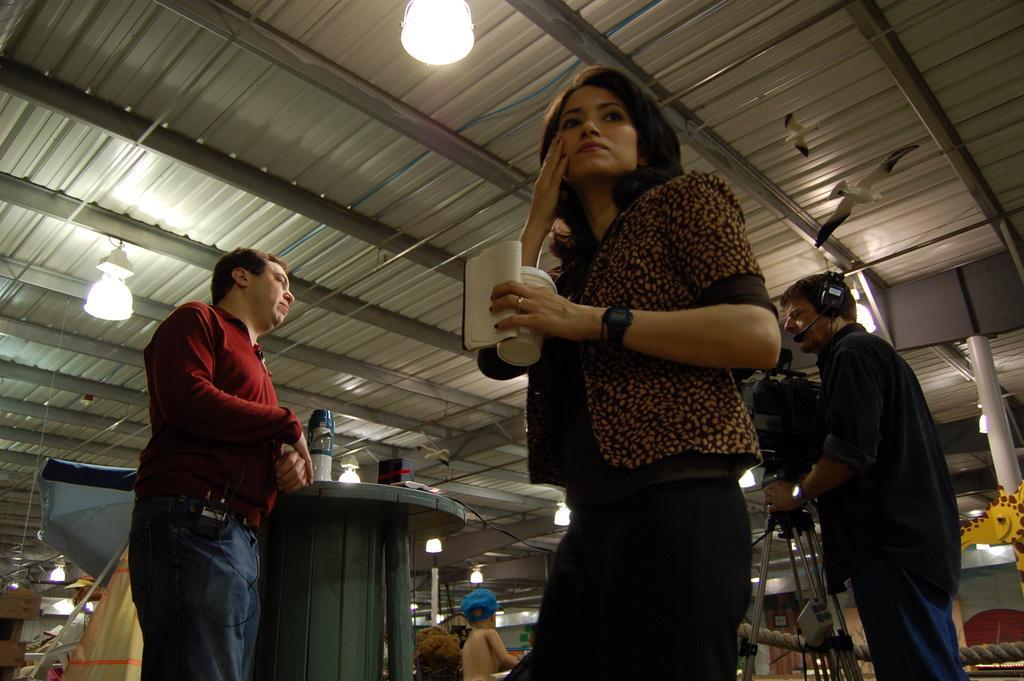Please provide a concise description of this image. There are two men and a woman standing. This woman is holding a book and a glass in her hand. This looks like a video recorder with a tripod stand. I can see few objects placed on the table. These are the lamps, which are hanging. At the bottom of the image, that looks like a boy with a cap. I think these are the artificial birds, which are flying. On the right side of the image, I can see a toy giraffe. This looks like a pole. 